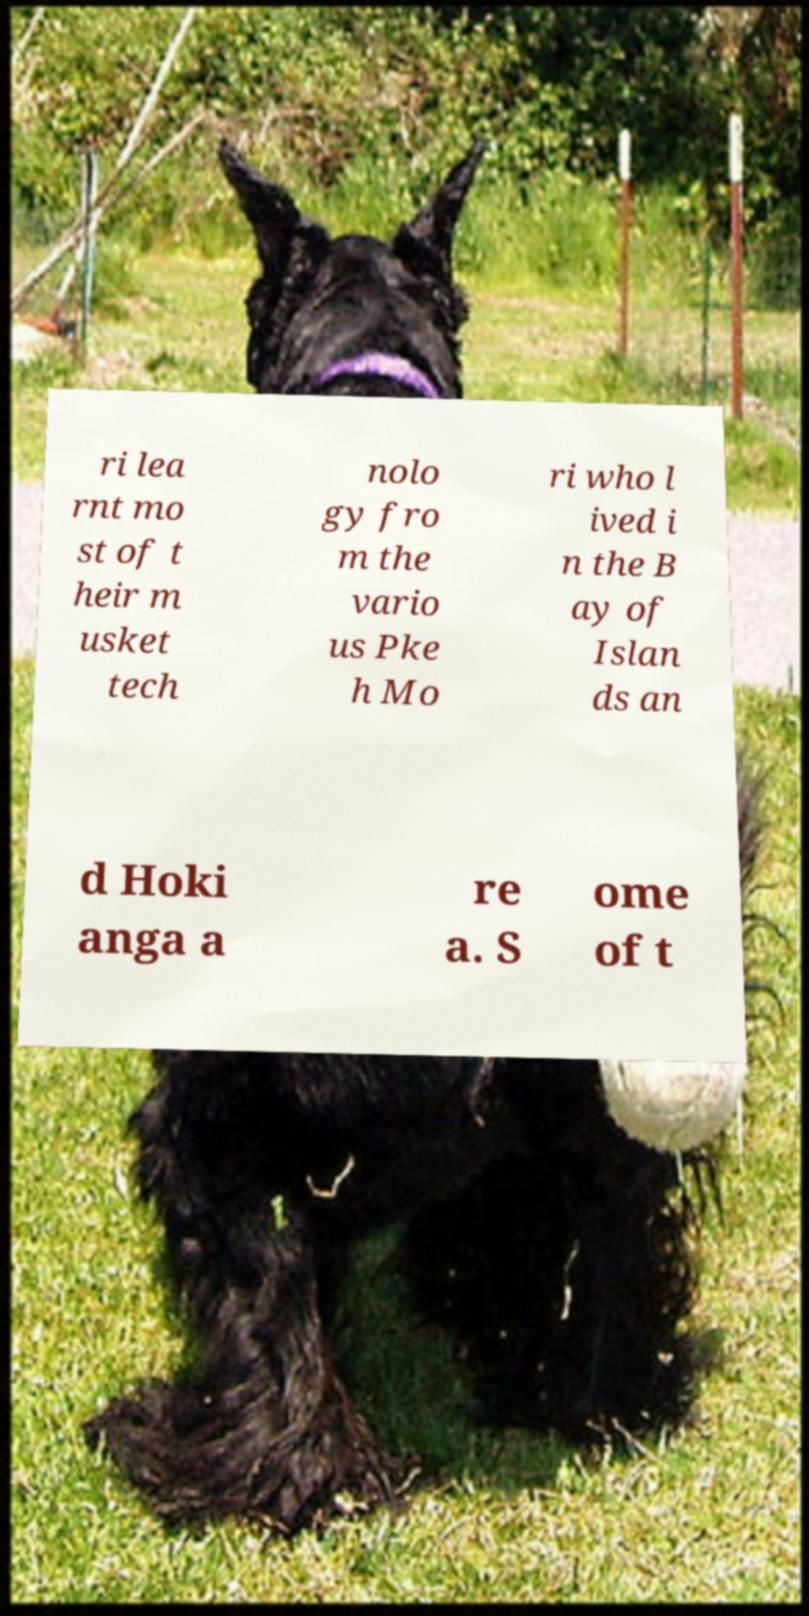Please read and relay the text visible in this image. What does it say? ri lea rnt mo st of t heir m usket tech nolo gy fro m the vario us Pke h Mo ri who l ived i n the B ay of Islan ds an d Hoki anga a re a. S ome of t 